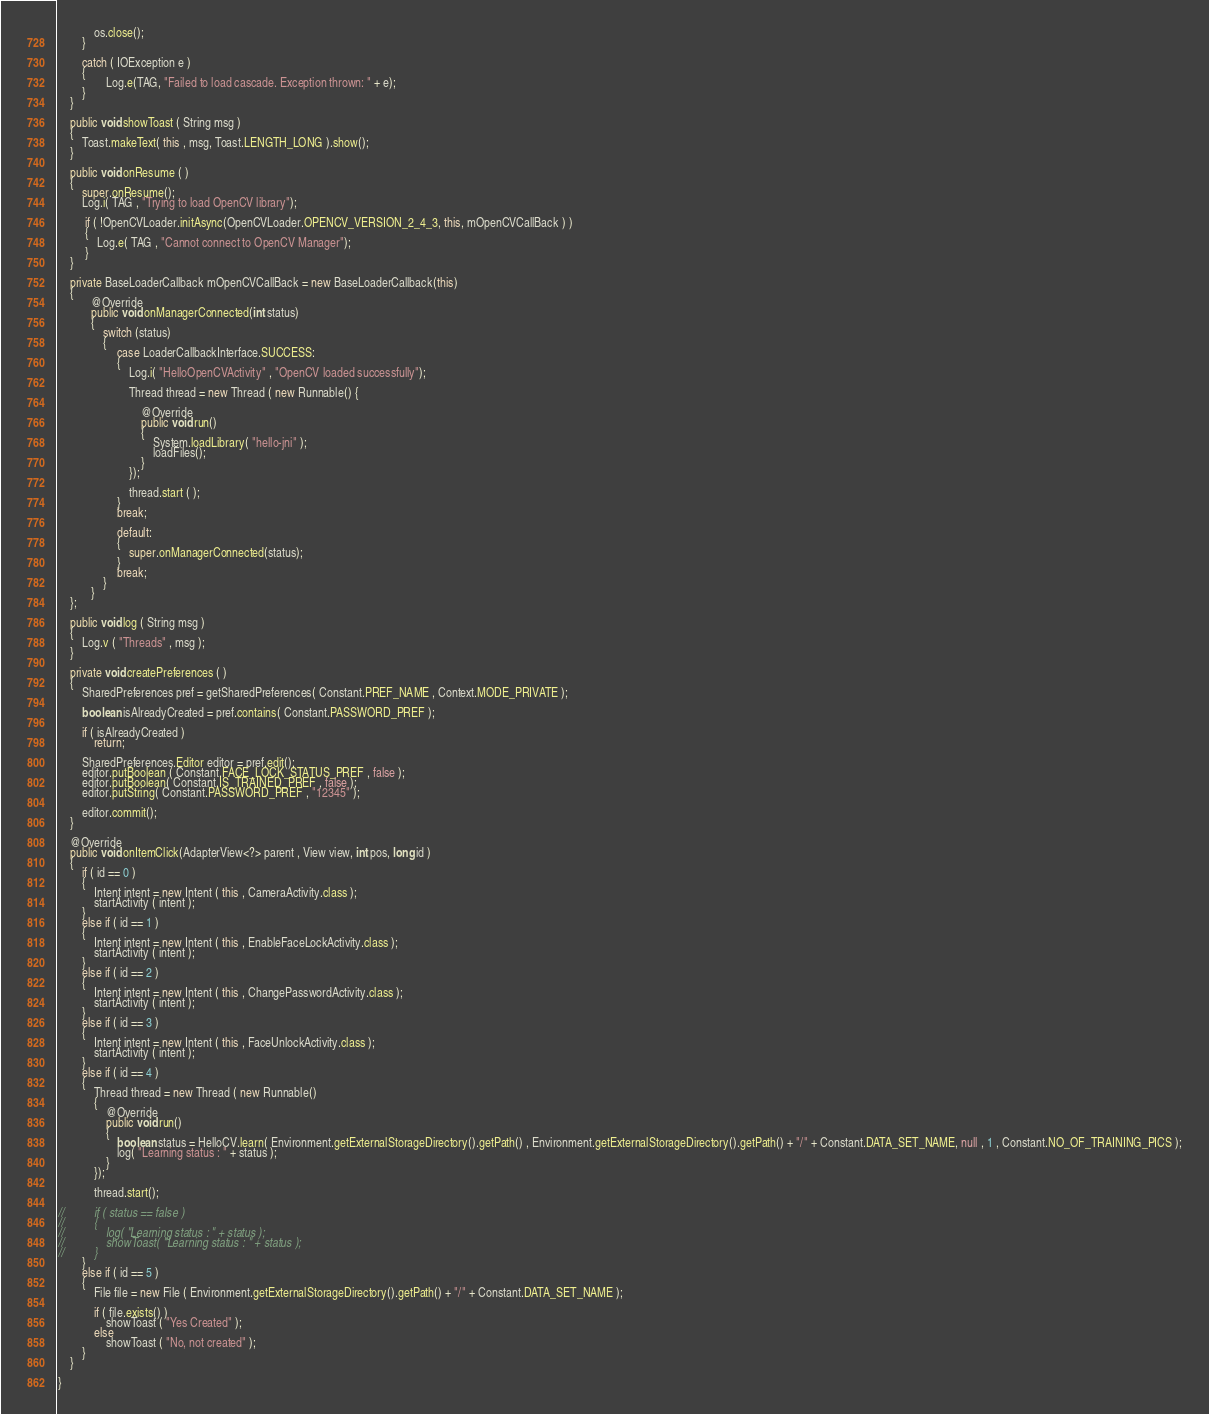Convert code to text. <code><loc_0><loc_0><loc_500><loc_500><_Java_>            os.close();
		}
		
    	catch ( IOException e )
		{
            	Log.e(TAG, "Failed to load cascade. Exception thrown: " + e);
		}
    }
    
    public void showToast ( String msg )
    {
    	Toast.makeText( this , msg, Toast.LENGTH_LONG ).show();
    }
    
    public void onResume ( )
    {
    	super.onResume();
    	Log.i( TAG , "Trying to load OpenCV library");
	 
		 if ( !OpenCVLoader.initAsync(OpenCVLoader.OPENCV_VERSION_2_4_3, this, mOpenCVCallBack ) )
		 {
			 Log.e( TAG , "Cannot connect to OpenCV Manager");
		 }
    }
    
	private BaseLoaderCallback mOpenCVCallBack = new BaseLoaderCallback(this) 
	{
		   @Override
		   public void onManagerConnected(int status) 
		   {
			   switch (status) 
			   {
		       		case LoaderCallbackInterface.SUCCESS:
		       		{
		       			Log.i( "HelloOpenCVActivity" , "OpenCV loaded successfully");
		       			
		       			Thread thread = new Thread ( new Runnable() {
							
							@Override
							public void run() 
							{
								System.loadLibrary( "hello-jni" );
			       				loadFiles();
							}
						});
		       				
		       			thread.start ( );
		       		}
		       		break;
		       		
		       		default:
		       		{
		       			super.onManagerConnected(status);
		       		} 
		       		break;
			   }
		   }
	};
	
	public void log ( String msg )
	{
		Log.v ( "Threads" , msg );
	}

	private void createPreferences ( )
	{
		SharedPreferences pref = getSharedPreferences( Constant.PREF_NAME , Context.MODE_PRIVATE );
		
		boolean isAlreadyCreated = pref.contains( Constant.PASSWORD_PREF );
		
		if ( isAlreadyCreated )
			return;
		
		SharedPreferences.Editor editor = pref.edit();
		editor.putBoolean ( Constant.FACE_LOCK_STATUS_PREF , false );
		editor.putBoolean( Constant.IS_TRAINED_PREF , false );
		editor.putString( Constant.PASSWORD_PREF , "12345" );
		
		editor.commit();
	}

	@Override
	public void onItemClick(AdapterView<?> parent , View view, int pos, long id ) 
	{
		if ( id == 0 )
		{
			Intent intent = new Intent ( this , CameraActivity.class );
			startActivity ( intent );
		}
		else if ( id == 1 )
		{
			Intent intent = new Intent ( this , EnableFaceLockActivity.class );
			startActivity ( intent );
		}
		else if ( id == 2 )
		{
			Intent intent = new Intent ( this , ChangePasswordActivity.class );
			startActivity ( intent );
		}
		else if ( id == 3 )
		{
			Intent intent = new Intent ( this , FaceUnlockActivity.class );
			startActivity ( intent );
		}
		else if ( id == 4 )
		{	
			Thread thread = new Thread ( new Runnable() 
			{
				@Override
				public void run() 
				{
					boolean status = HelloCV.learn( Environment.getExternalStorageDirectory().getPath() , Environment.getExternalStorageDirectory().getPath() + "/" + Constant.DATA_SET_NAME, null , 1 , Constant.NO_OF_TRAINING_PICS );
					log( "Learning status : " + status );
				}
			});
			
			thread.start();
			
//			if ( status == false )
//			{
//				log( "Learning status : " + status );
//				showToast( "Learning status : " + status );
//			}
		}
		else if ( id == 5 )
		{
			File file = new File ( Environment.getExternalStorageDirectory().getPath() + "/" + Constant.DATA_SET_NAME );
			
			if ( file.exists() )
				showToast ( "Yes Created" );
			else
				showToast ( "No, not created" );
		}
	}

}
</code> 